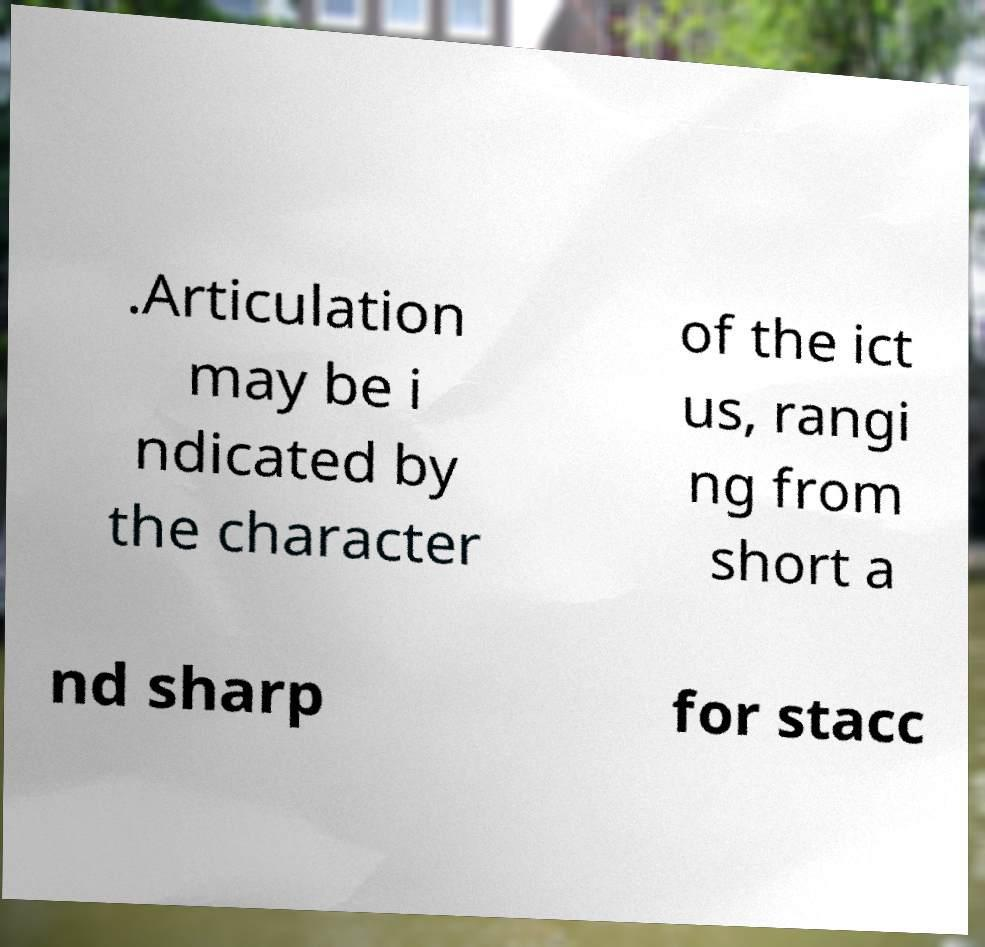What messages or text are displayed in this image? I need them in a readable, typed format. .Articulation may be i ndicated by the character of the ict us, rangi ng from short a nd sharp for stacc 